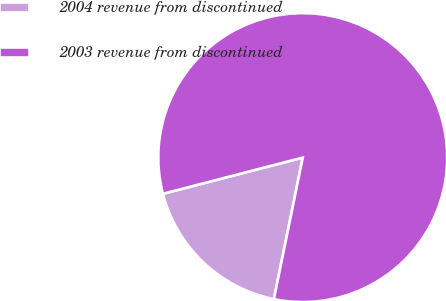Convert chart to OTSL. <chart><loc_0><loc_0><loc_500><loc_500><pie_chart><fcel>2004 revenue from discontinued<fcel>2003 revenue from discontinued<nl><fcel>17.77%<fcel>82.23%<nl></chart> 